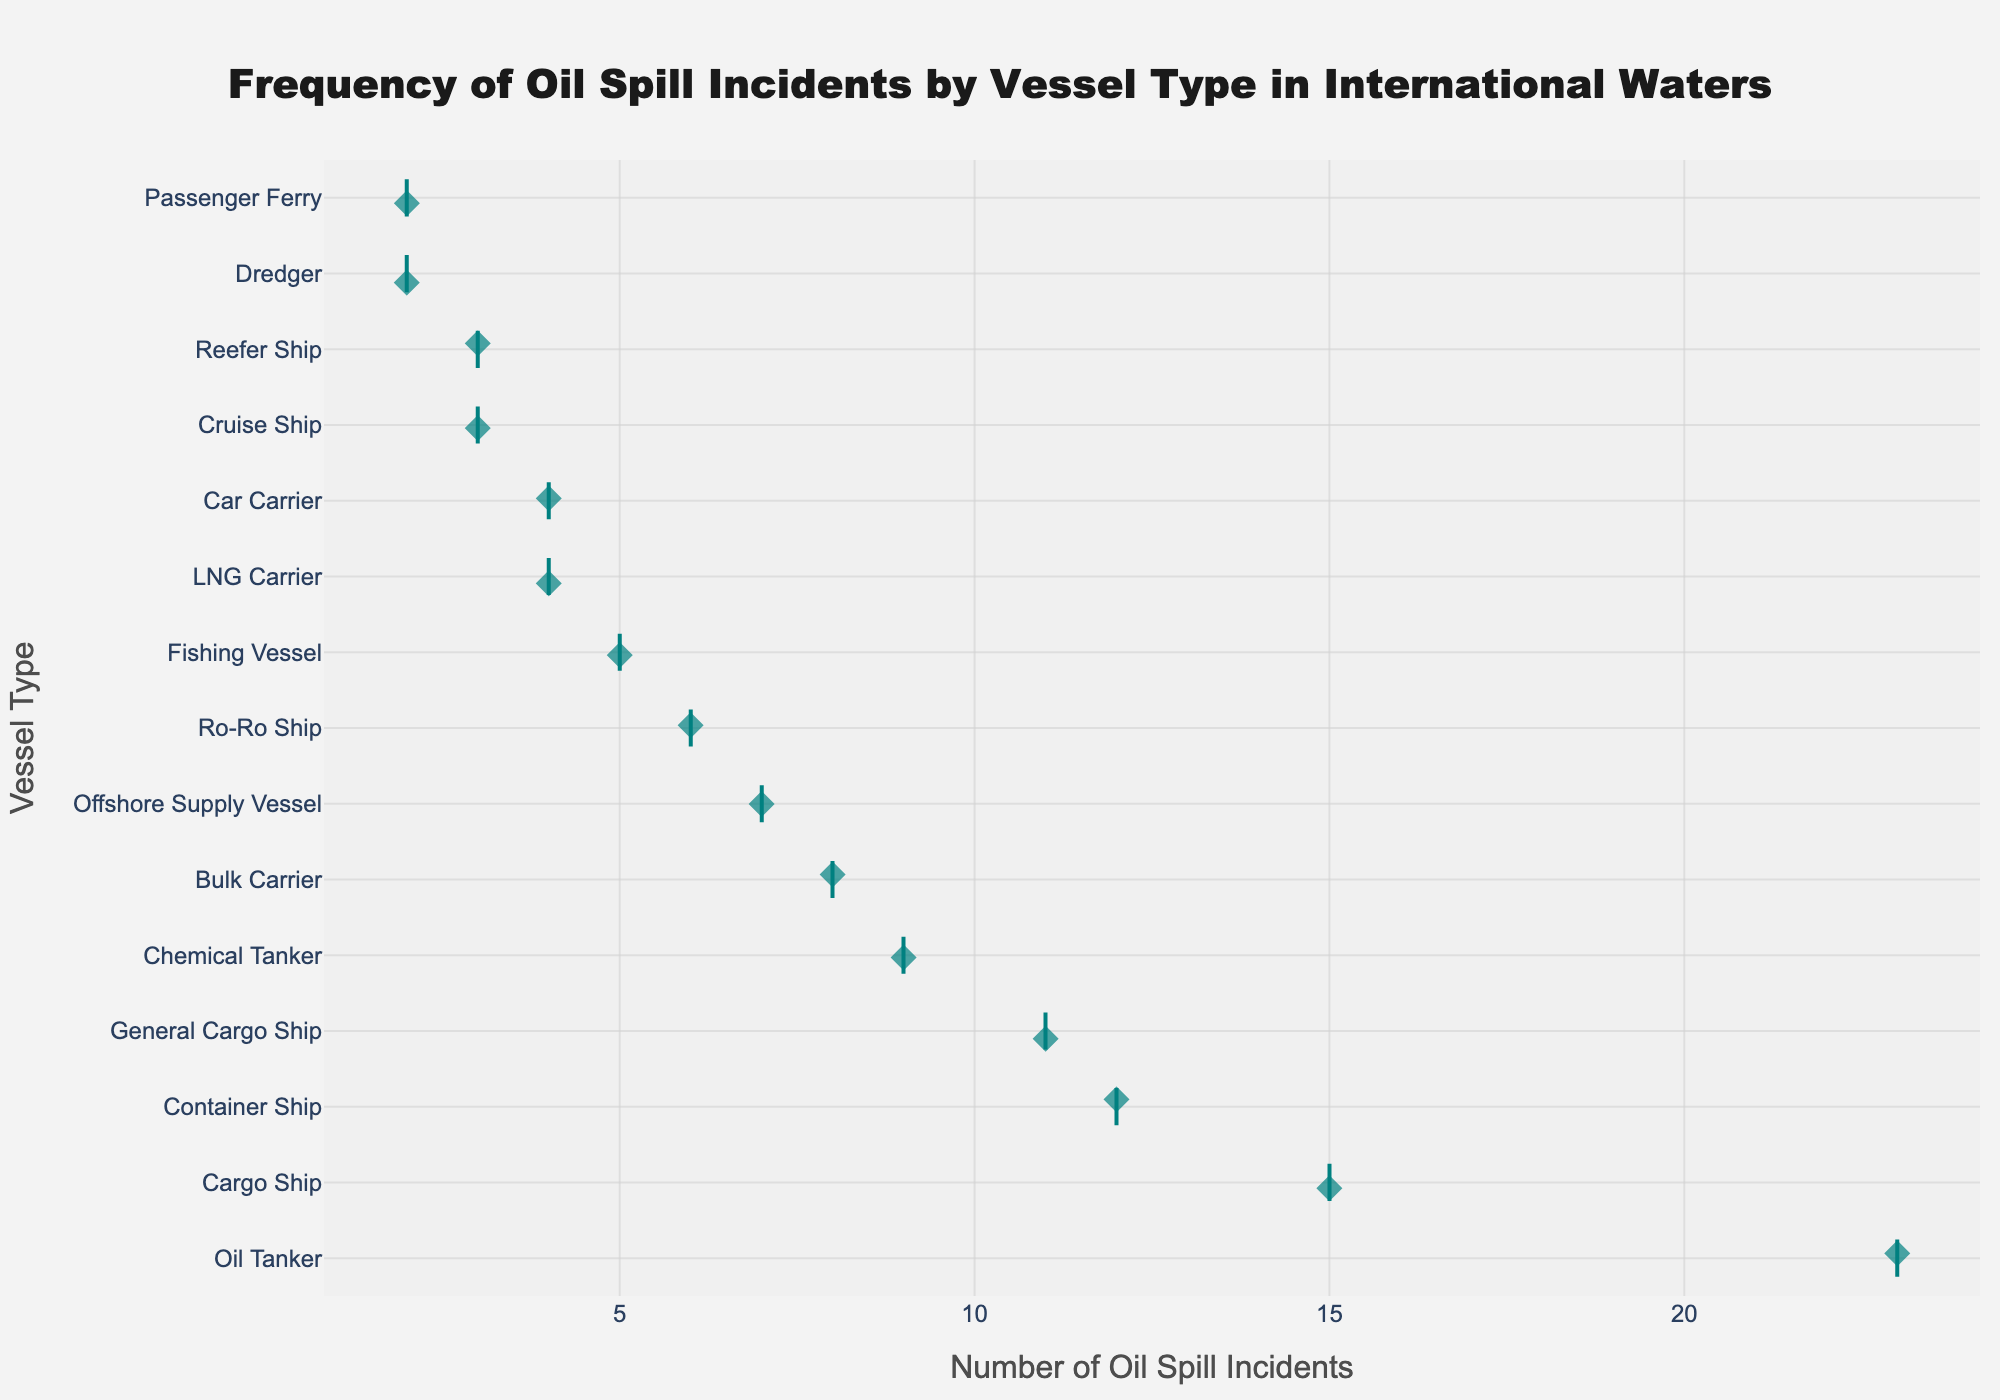What is the title of the plot? The title is positioned at the top center of the plot and describes the topic of the data presented.
Answer: Frequency of Oil Spill Incidents by Vessel Type in International Waters Which vessel type has the highest number of oil spill incidents? By looking at the horizontal axis, the vessel type at the farthest right of the plot has the highest number of oil spill incidents.
Answer: Oil Tanker How many oil spill incidents are associated with Chemical Tankers? Locate the "Chemical Tanker" label on the vertical axis and look horizontally to see the number of incidents aligned with it.
Answer: 9 Are there any vessel types with the same number of oil spill incidents? Look for multiple points that align horizontally at the same position on the horizontal axis.
Answer: Yes, Passenger Ferry and Dredger both have 2 incidents each, and Cruise Ship and Reefer Ship both have 3 incidents each How does the sum of oil spill incidents for Oil Tankers and Cargo Ships compare to the sum for Container Ships and Chemical Tankers? Add up the incidents for Oil Tankers (23) and Cargo Ships (15) to get 38, and do the same for Container Ships (12) and Chemical Tankers (9) to get 21. Compare the two sums.
Answer: 38 vs. 21 Which vessel type has fewer oil spill incidents, Ro-Ro Ship or LNG Carrier? Compare the horizontal positions of the points corresponding to Ro-Ro Ship and LNG Carrier on the plot to see which is smaller.
Answer: LNG Carrier What is the total number of oil spill incidents for all vessel types shown on the plot? Add all the numbers of incidents together: 23 + 12 + 8 + 5 + 3 + 15 + 9 + 4 + 6 + 7 + 2 + 3 + 4 + 11 + 2.
Answer: 114 Are the oil spill incidents for Offshore Supply Vessels higher or lower than that for Bulk Carriers? Compare the horizontal positions of the points corresponding to Offshore Supply Vessels and Bulk Carriers on the plot.
Answer: Higher What is the median number of oil spill incidents across all vessel types? Sort all incident numbers and find the middle value(s). If there's an even number of values, find the average of the two middle values. The incidents are [2, 2, 3, 3, 4, 4, 5, 6, 7, 8, 9, 11, 12, 15, 23]. The median is the middle value, the 8th number.
Answer: 6 Which vessel types have fewer than 5 oil spill incidents? Identify vessel types where the points lie to the left of the mark for 5 incidents.
Answer: Fishing Vessel, LNG Carrier, Dredger, Reefer Ship, Car Carrier, Passenger Ferry 